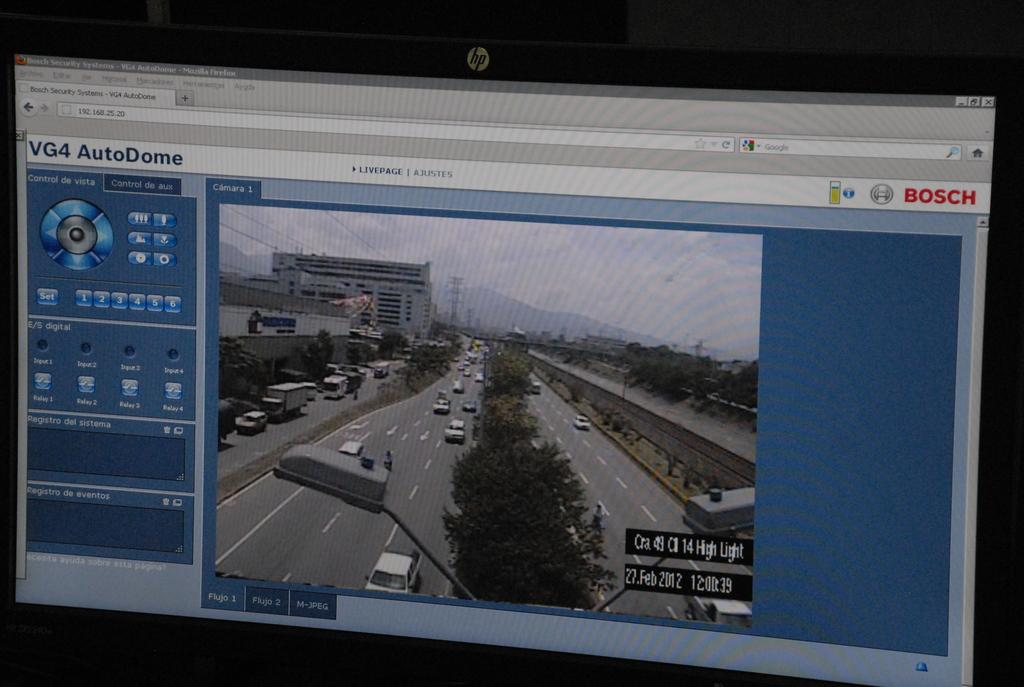<image>
Describe the image concisely. a firefox page that is open to 'vg4 autodome' 